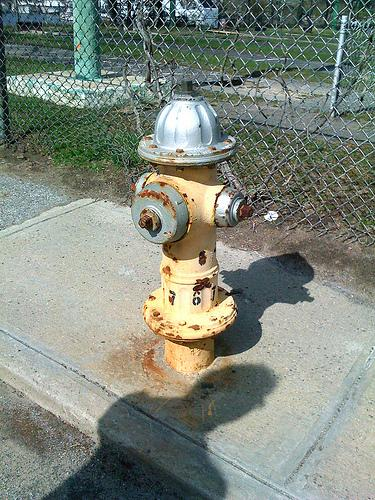Question: how is the photo?
Choices:
A. Good.
B. Clear.
C. Bright.
D. High quality.
Answer with the letter. Answer: B Question: what is yellow?
Choices:
A. The truck.
B. The sign.
C. The van.
D. The hydrant.
Answer with the letter. Answer: D 